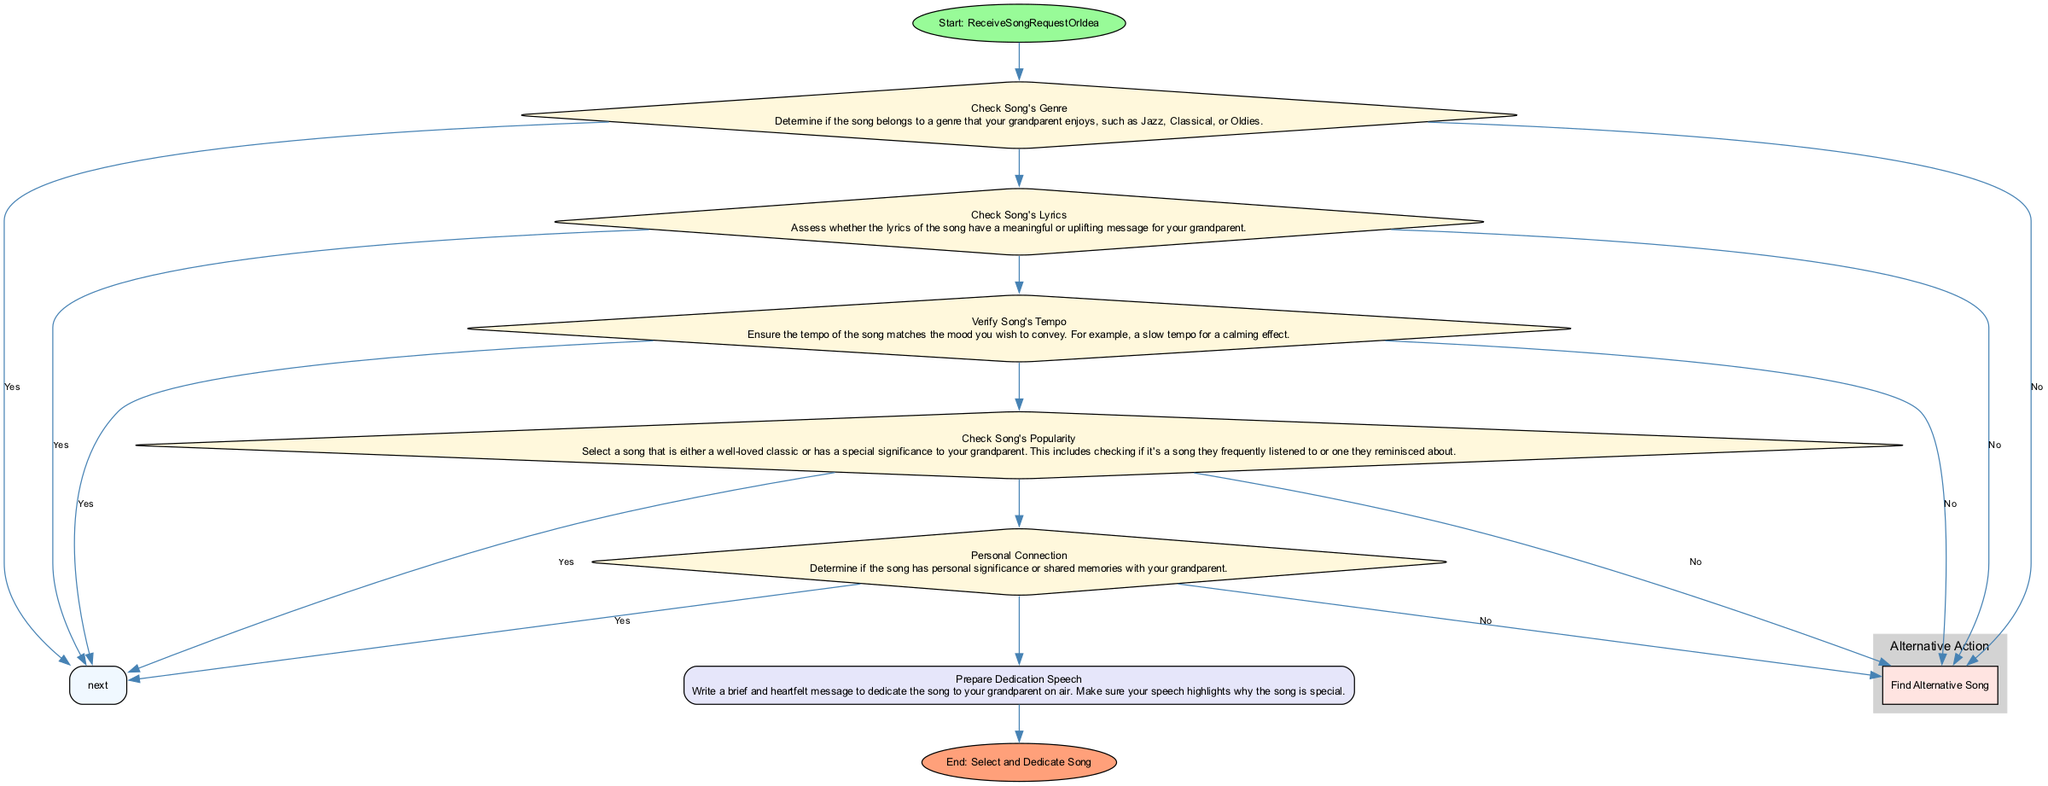What's the starting point of the flowchart? The flowchart starts with a node labeled "ReceiveSongRequestOrIdea," which indicates the initial action in the process of selecting the perfect song.
Answer: ReceiveSongRequestOrIdea How many decision nodes are there in the diagram? By reviewing the diagram, we can count a total of five decision nodes that require a yes or no response before proceeding.
Answer: Five What does the last action step entail? The last action step listed in the diagram is "Prepare Dedication Speech," which involves writing a heartfelt message for the song dedication.
Answer: Prepare Dedication Speech What happens if the song's genre is not one that your grandparent enjoys? If the song's genre is not one that your grandparent enjoys, the flowchart indicates that you should "Find Alternative Song."
Answer: Find Alternative Song Which step follows after verifying the song's tempo? The step that follows after verifying the song's tempo is "Check Song's Popularity," which continues the decision-making process.
Answer: Check Song's Popularity What is the purpose of the "Personal Connection" decision step? The "Personal Connection" decision step aims to determine whether the song has personal significance or shared memories with your grandparent, impacting the song selection process.
Answer: To determine personal significance What significance does the "Check Song's Popularity" step have in the process? This step is crucial as it allows you to select a song that either holds special meaning for your grandparent or is a well-loved classic they reminisce about, influencing your choice of song.
Answer: Special meaning or classic What node comes after checking the song's lyrics if the response is 'no'? If the response to checking the song's lyrics is 'no,' the flowchart directs you to "Find Alternative Song," indicating a need for a different choice.
Answer: Find Alternative Song What action follows after the last decision node if all answers are 'yes'? If all the answers to the decision nodes are 'yes,' the flowchart leads directly to "Prepare Dedication Speech," indicating readiness to dedicate the song.
Answer: Prepare Dedication Speech 